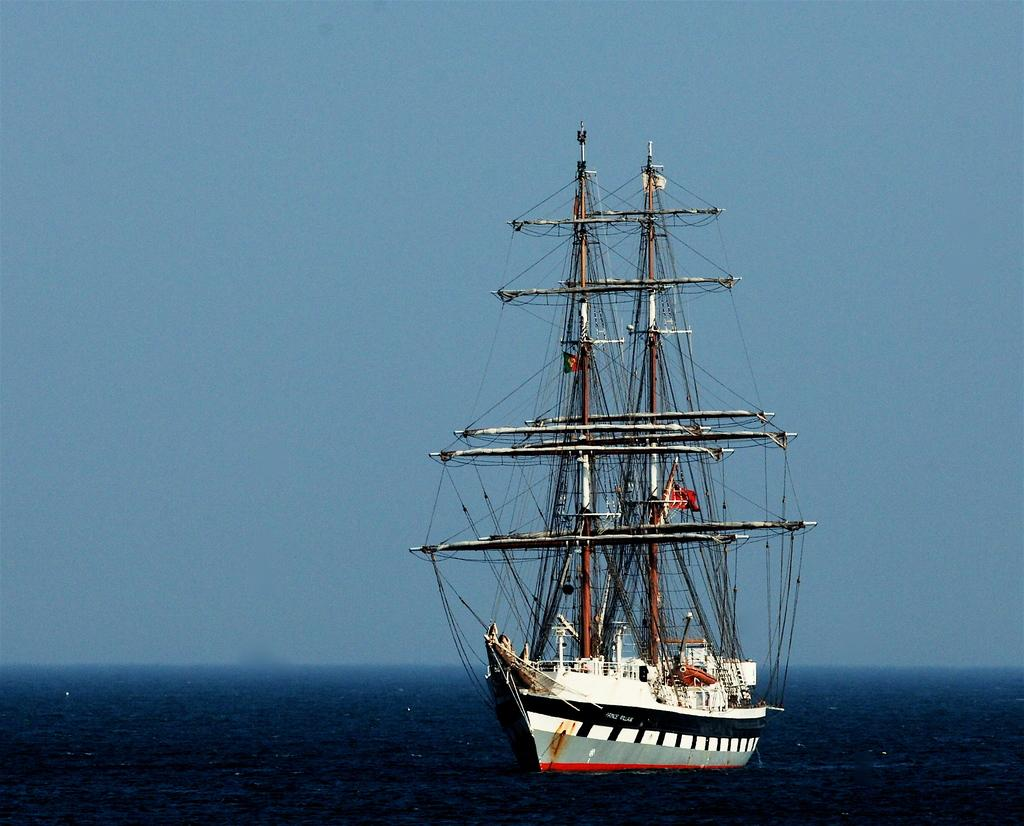What is the main subject of the image? There is a ship in the image. Where is the ship located? The ship is on the water. What can be seen in the background of the image? There is sky visible in the background of the image. What type of lettuce can be seen floating near the ship in the image? There is no lettuce present in the image; it features a ship on the water with sky visible in the background. 